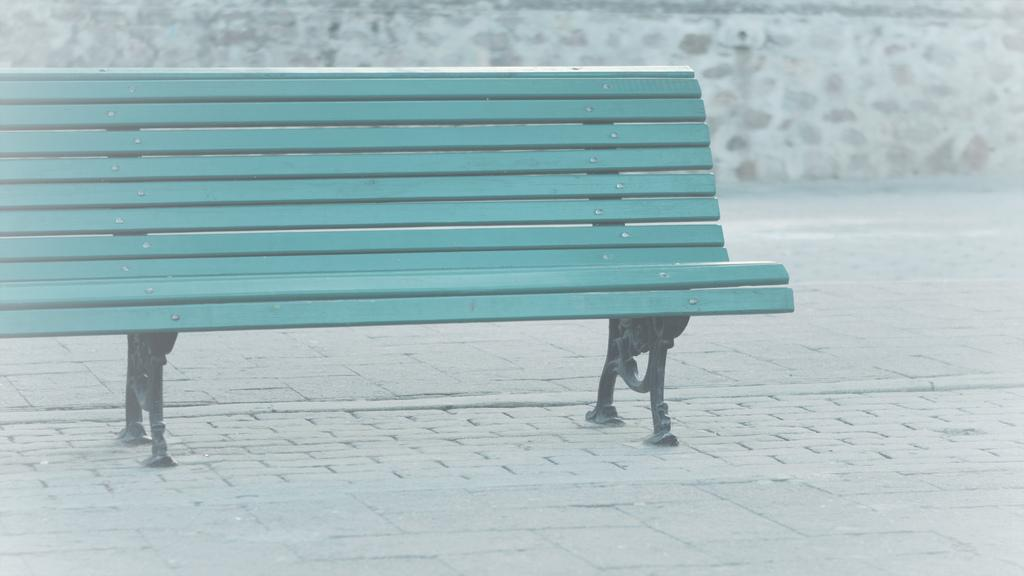What type of seating is visible in the image? There is a bench in the image. Where is the bench located? The bench is on the ground. What color is the bench? The bench is painted blue. What is behind the bench in the image? There is a wall behind the bench. Can you see a giraffe standing next to the bench in the image? No, there is no giraffe present in the image. Is there a tub visible near the bench in the image? No, there is no tub present in the image. 